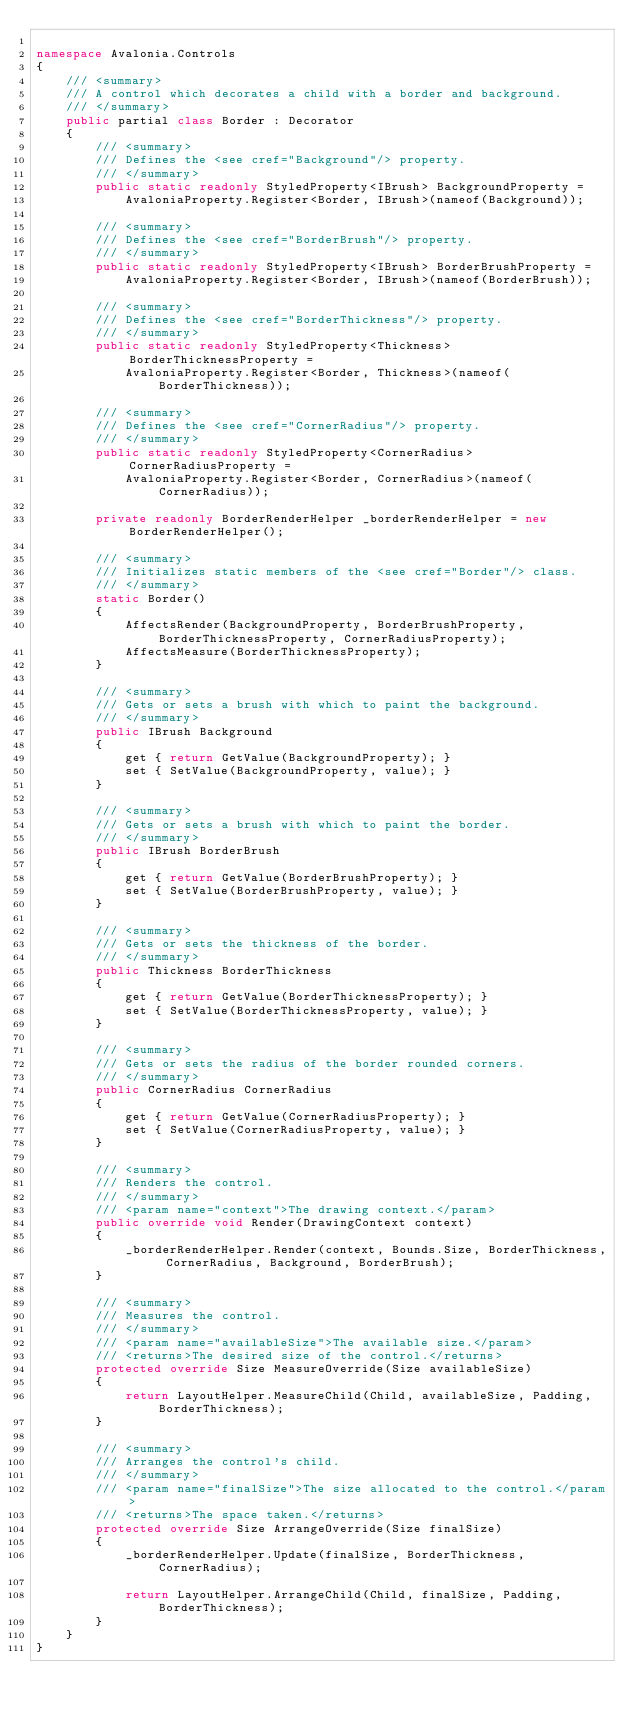Convert code to text. <code><loc_0><loc_0><loc_500><loc_500><_C#_>
namespace Avalonia.Controls
{
    /// <summary>
    /// A control which decorates a child with a border and background.
    /// </summary>
    public partial class Border : Decorator
    {
        /// <summary>
        /// Defines the <see cref="Background"/> property.
        /// </summary>
        public static readonly StyledProperty<IBrush> BackgroundProperty =
            AvaloniaProperty.Register<Border, IBrush>(nameof(Background));

        /// <summary>
        /// Defines the <see cref="BorderBrush"/> property.
        /// </summary>
        public static readonly StyledProperty<IBrush> BorderBrushProperty =
            AvaloniaProperty.Register<Border, IBrush>(nameof(BorderBrush));

        /// <summary>
        /// Defines the <see cref="BorderThickness"/> property.
        /// </summary>
        public static readonly StyledProperty<Thickness> BorderThicknessProperty =
            AvaloniaProperty.Register<Border, Thickness>(nameof(BorderThickness));

        /// <summary>
        /// Defines the <see cref="CornerRadius"/> property.
        /// </summary>
        public static readonly StyledProperty<CornerRadius> CornerRadiusProperty =
            AvaloniaProperty.Register<Border, CornerRadius>(nameof(CornerRadius));

        private readonly BorderRenderHelper _borderRenderHelper = new BorderRenderHelper();

        /// <summary>
        /// Initializes static members of the <see cref="Border"/> class.
        /// </summary>
        static Border()
        {
            AffectsRender(BackgroundProperty, BorderBrushProperty, BorderThicknessProperty, CornerRadiusProperty);
            AffectsMeasure(BorderThicknessProperty);
        }

        /// <summary>
        /// Gets or sets a brush with which to paint the background.
        /// </summary>
        public IBrush Background
        {
            get { return GetValue(BackgroundProperty); }
            set { SetValue(BackgroundProperty, value); }
        }

        /// <summary>
        /// Gets or sets a brush with which to paint the border.
        /// </summary>
        public IBrush BorderBrush
        {
            get { return GetValue(BorderBrushProperty); }
            set { SetValue(BorderBrushProperty, value); }
        }

        /// <summary>
        /// Gets or sets the thickness of the border.
        /// </summary>
        public Thickness BorderThickness
        {
            get { return GetValue(BorderThicknessProperty); }
            set { SetValue(BorderThicknessProperty, value); }
        }

        /// <summary>
        /// Gets or sets the radius of the border rounded corners.
        /// </summary>
        public CornerRadius CornerRadius
        {
            get { return GetValue(CornerRadiusProperty); }
            set { SetValue(CornerRadiusProperty, value); }
        }

        /// <summary>
        /// Renders the control.
        /// </summary>
        /// <param name="context">The drawing context.</param>
        public override void Render(DrawingContext context)
        {
            _borderRenderHelper.Render(context, Bounds.Size, BorderThickness, CornerRadius, Background, BorderBrush);
        }

        /// <summary>
        /// Measures the control.
        /// </summary>
        /// <param name="availableSize">The available size.</param>
        /// <returns>The desired size of the control.</returns>
        protected override Size MeasureOverride(Size availableSize)
        {
            return LayoutHelper.MeasureChild(Child, availableSize, Padding, BorderThickness);
        }

        /// <summary>
        /// Arranges the control's child.
        /// </summary>
        /// <param name="finalSize">The size allocated to the control.</param>
        /// <returns>The space taken.</returns>
        protected override Size ArrangeOverride(Size finalSize)
        {
            _borderRenderHelper.Update(finalSize, BorderThickness, CornerRadius);

            return LayoutHelper.ArrangeChild(Child, finalSize, Padding, BorderThickness);
        }
    }
}</code> 